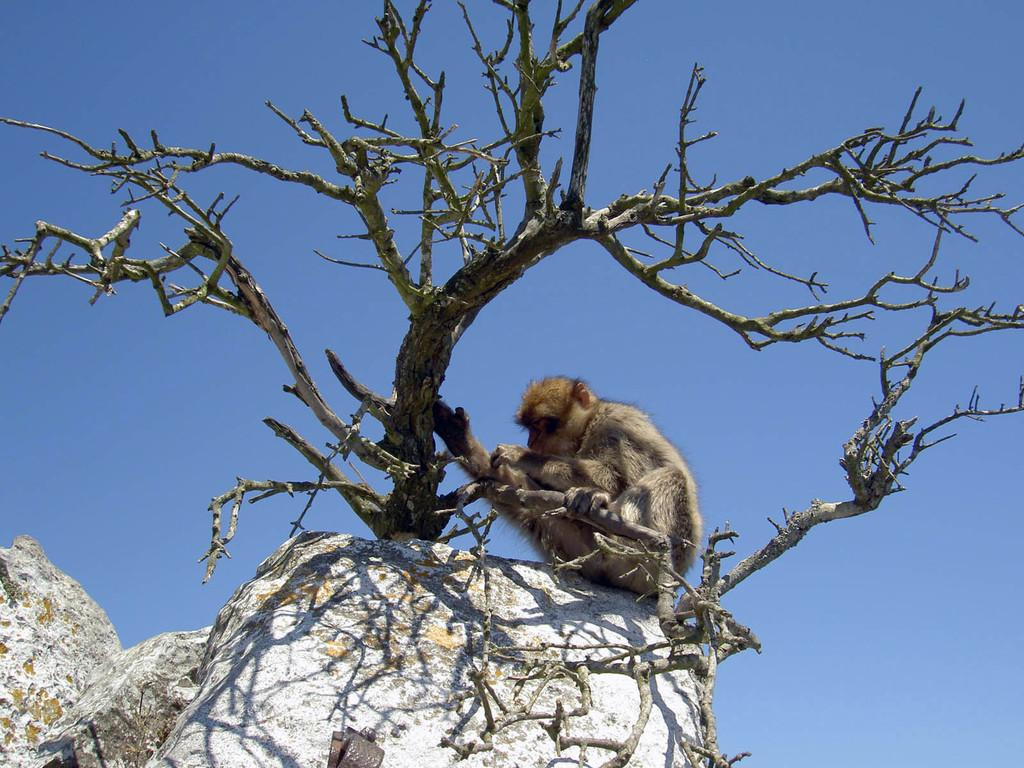What animal is present in the picture? There is a monkey in the picture. Where is the monkey sitting? The monkey is sitting on a stone. What is the location of the stone in the picture? The stone is in the middle of the picture. What can be seen in front of the monkey? There is a tree in front of the monkey. How many cherries are on the van in the image? There is no van or cherries present in the image. 